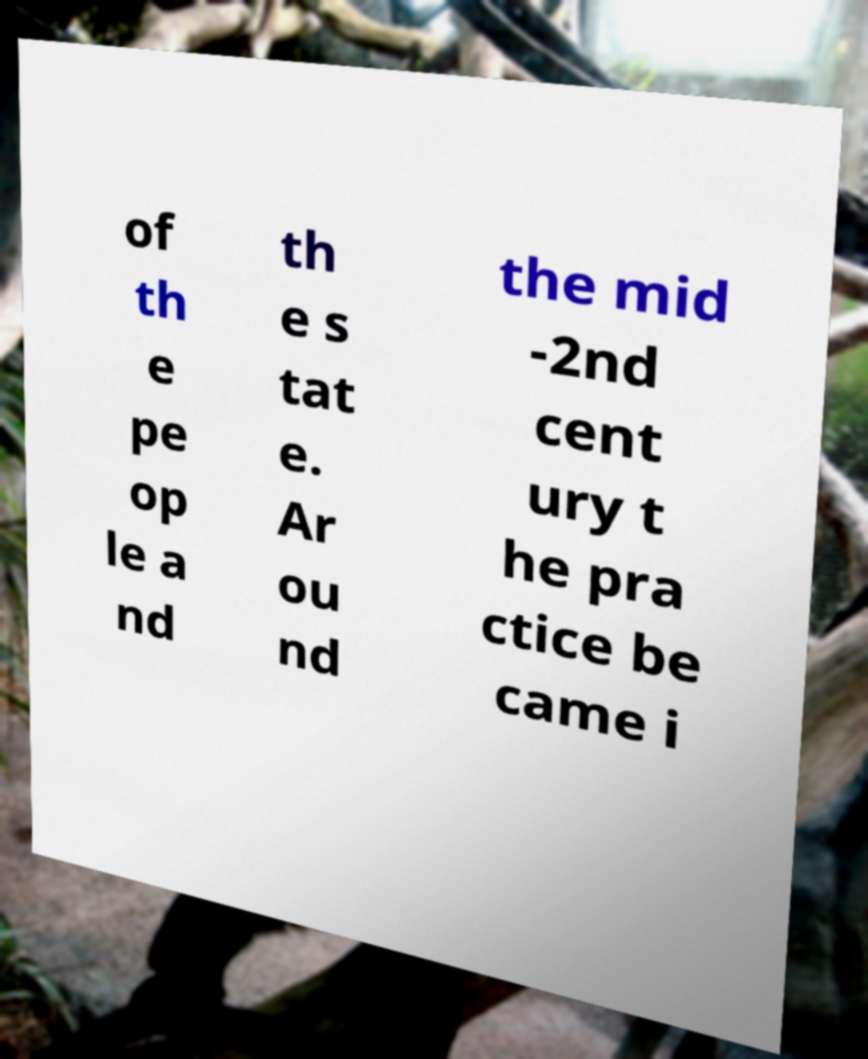I need the written content from this picture converted into text. Can you do that? of th e pe op le a nd th e s tat e. Ar ou nd the mid -2nd cent ury t he pra ctice be came i 